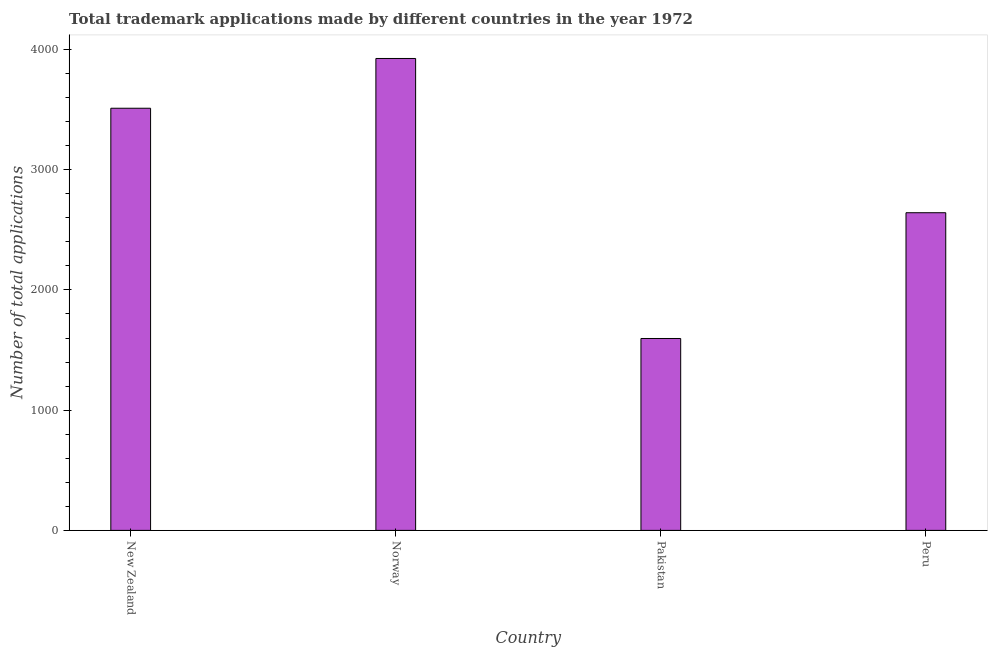Does the graph contain grids?
Provide a succinct answer. No. What is the title of the graph?
Your answer should be very brief. Total trademark applications made by different countries in the year 1972. What is the label or title of the X-axis?
Your answer should be compact. Country. What is the label or title of the Y-axis?
Offer a very short reply. Number of total applications. What is the number of trademark applications in Peru?
Make the answer very short. 2642. Across all countries, what is the maximum number of trademark applications?
Provide a succinct answer. 3925. Across all countries, what is the minimum number of trademark applications?
Offer a very short reply. 1596. In which country was the number of trademark applications maximum?
Give a very brief answer. Norway. What is the sum of the number of trademark applications?
Provide a short and direct response. 1.17e+04. What is the difference between the number of trademark applications in Norway and Peru?
Ensure brevity in your answer.  1283. What is the average number of trademark applications per country?
Provide a short and direct response. 2918. What is the median number of trademark applications?
Keep it short and to the point. 3076.5. In how many countries, is the number of trademark applications greater than 800 ?
Your answer should be compact. 4. What is the ratio of the number of trademark applications in Pakistan to that in Peru?
Provide a succinct answer. 0.6. Is the number of trademark applications in New Zealand less than that in Peru?
Your answer should be very brief. No. Is the difference between the number of trademark applications in Pakistan and Peru greater than the difference between any two countries?
Provide a succinct answer. No. What is the difference between the highest and the second highest number of trademark applications?
Ensure brevity in your answer.  414. Is the sum of the number of trademark applications in New Zealand and Pakistan greater than the maximum number of trademark applications across all countries?
Your answer should be very brief. Yes. What is the difference between the highest and the lowest number of trademark applications?
Offer a terse response. 2329. In how many countries, is the number of trademark applications greater than the average number of trademark applications taken over all countries?
Ensure brevity in your answer.  2. How many bars are there?
Give a very brief answer. 4. What is the difference between two consecutive major ticks on the Y-axis?
Provide a short and direct response. 1000. What is the Number of total applications in New Zealand?
Provide a short and direct response. 3511. What is the Number of total applications in Norway?
Your answer should be very brief. 3925. What is the Number of total applications of Pakistan?
Your answer should be very brief. 1596. What is the Number of total applications in Peru?
Your answer should be very brief. 2642. What is the difference between the Number of total applications in New Zealand and Norway?
Give a very brief answer. -414. What is the difference between the Number of total applications in New Zealand and Pakistan?
Provide a short and direct response. 1915. What is the difference between the Number of total applications in New Zealand and Peru?
Your response must be concise. 869. What is the difference between the Number of total applications in Norway and Pakistan?
Ensure brevity in your answer.  2329. What is the difference between the Number of total applications in Norway and Peru?
Offer a very short reply. 1283. What is the difference between the Number of total applications in Pakistan and Peru?
Your response must be concise. -1046. What is the ratio of the Number of total applications in New Zealand to that in Norway?
Make the answer very short. 0.9. What is the ratio of the Number of total applications in New Zealand to that in Peru?
Provide a succinct answer. 1.33. What is the ratio of the Number of total applications in Norway to that in Pakistan?
Provide a short and direct response. 2.46. What is the ratio of the Number of total applications in Norway to that in Peru?
Offer a terse response. 1.49. What is the ratio of the Number of total applications in Pakistan to that in Peru?
Keep it short and to the point. 0.6. 